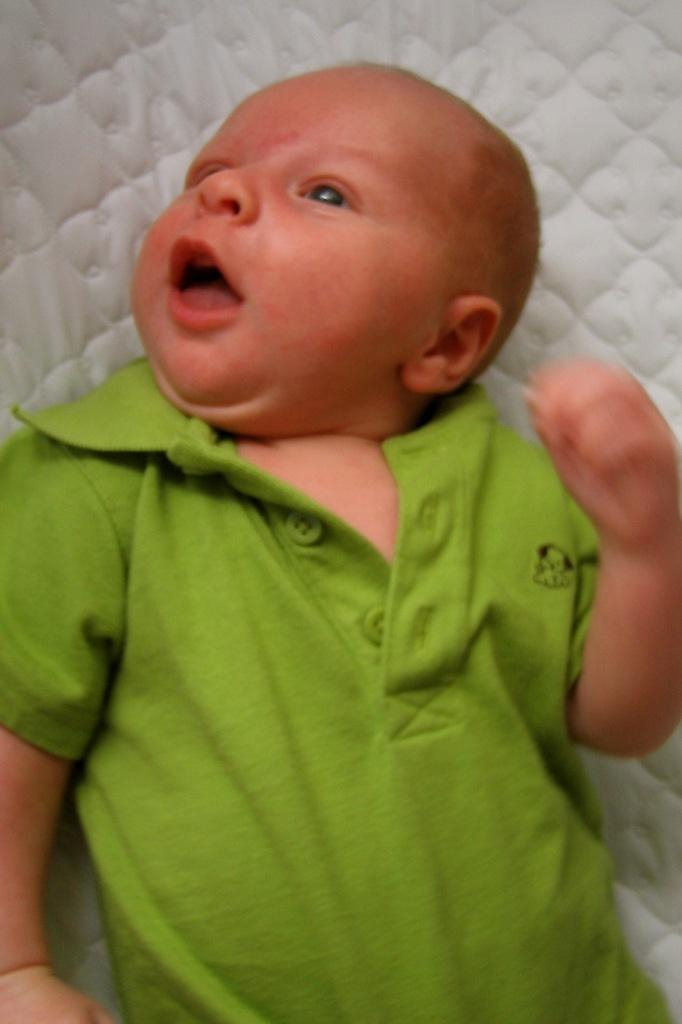What is the main subject of the image? There is a baby in the image. Where is the baby located? The baby is lying on a bed. How is the baby positioned in the image? The baby is in the center of the image. What type of coast can be seen in the background of the image? There is no coast visible in the image; it features a baby lying on a bed. Is there a kite flying in the image? No, there is no kite present in the image. 